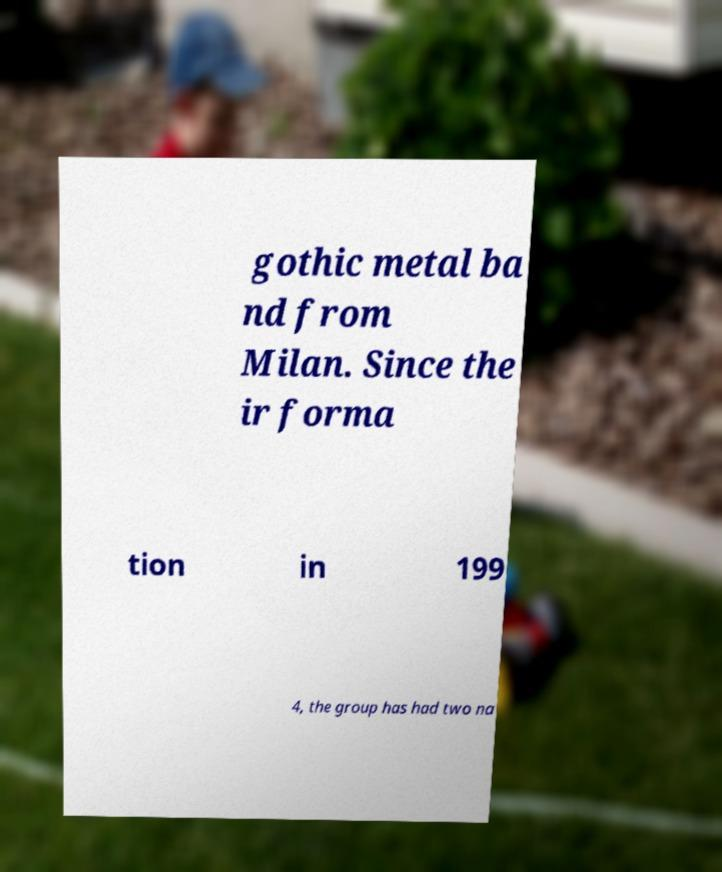Can you accurately transcribe the text from the provided image for me? gothic metal ba nd from Milan. Since the ir forma tion in 199 4, the group has had two na 